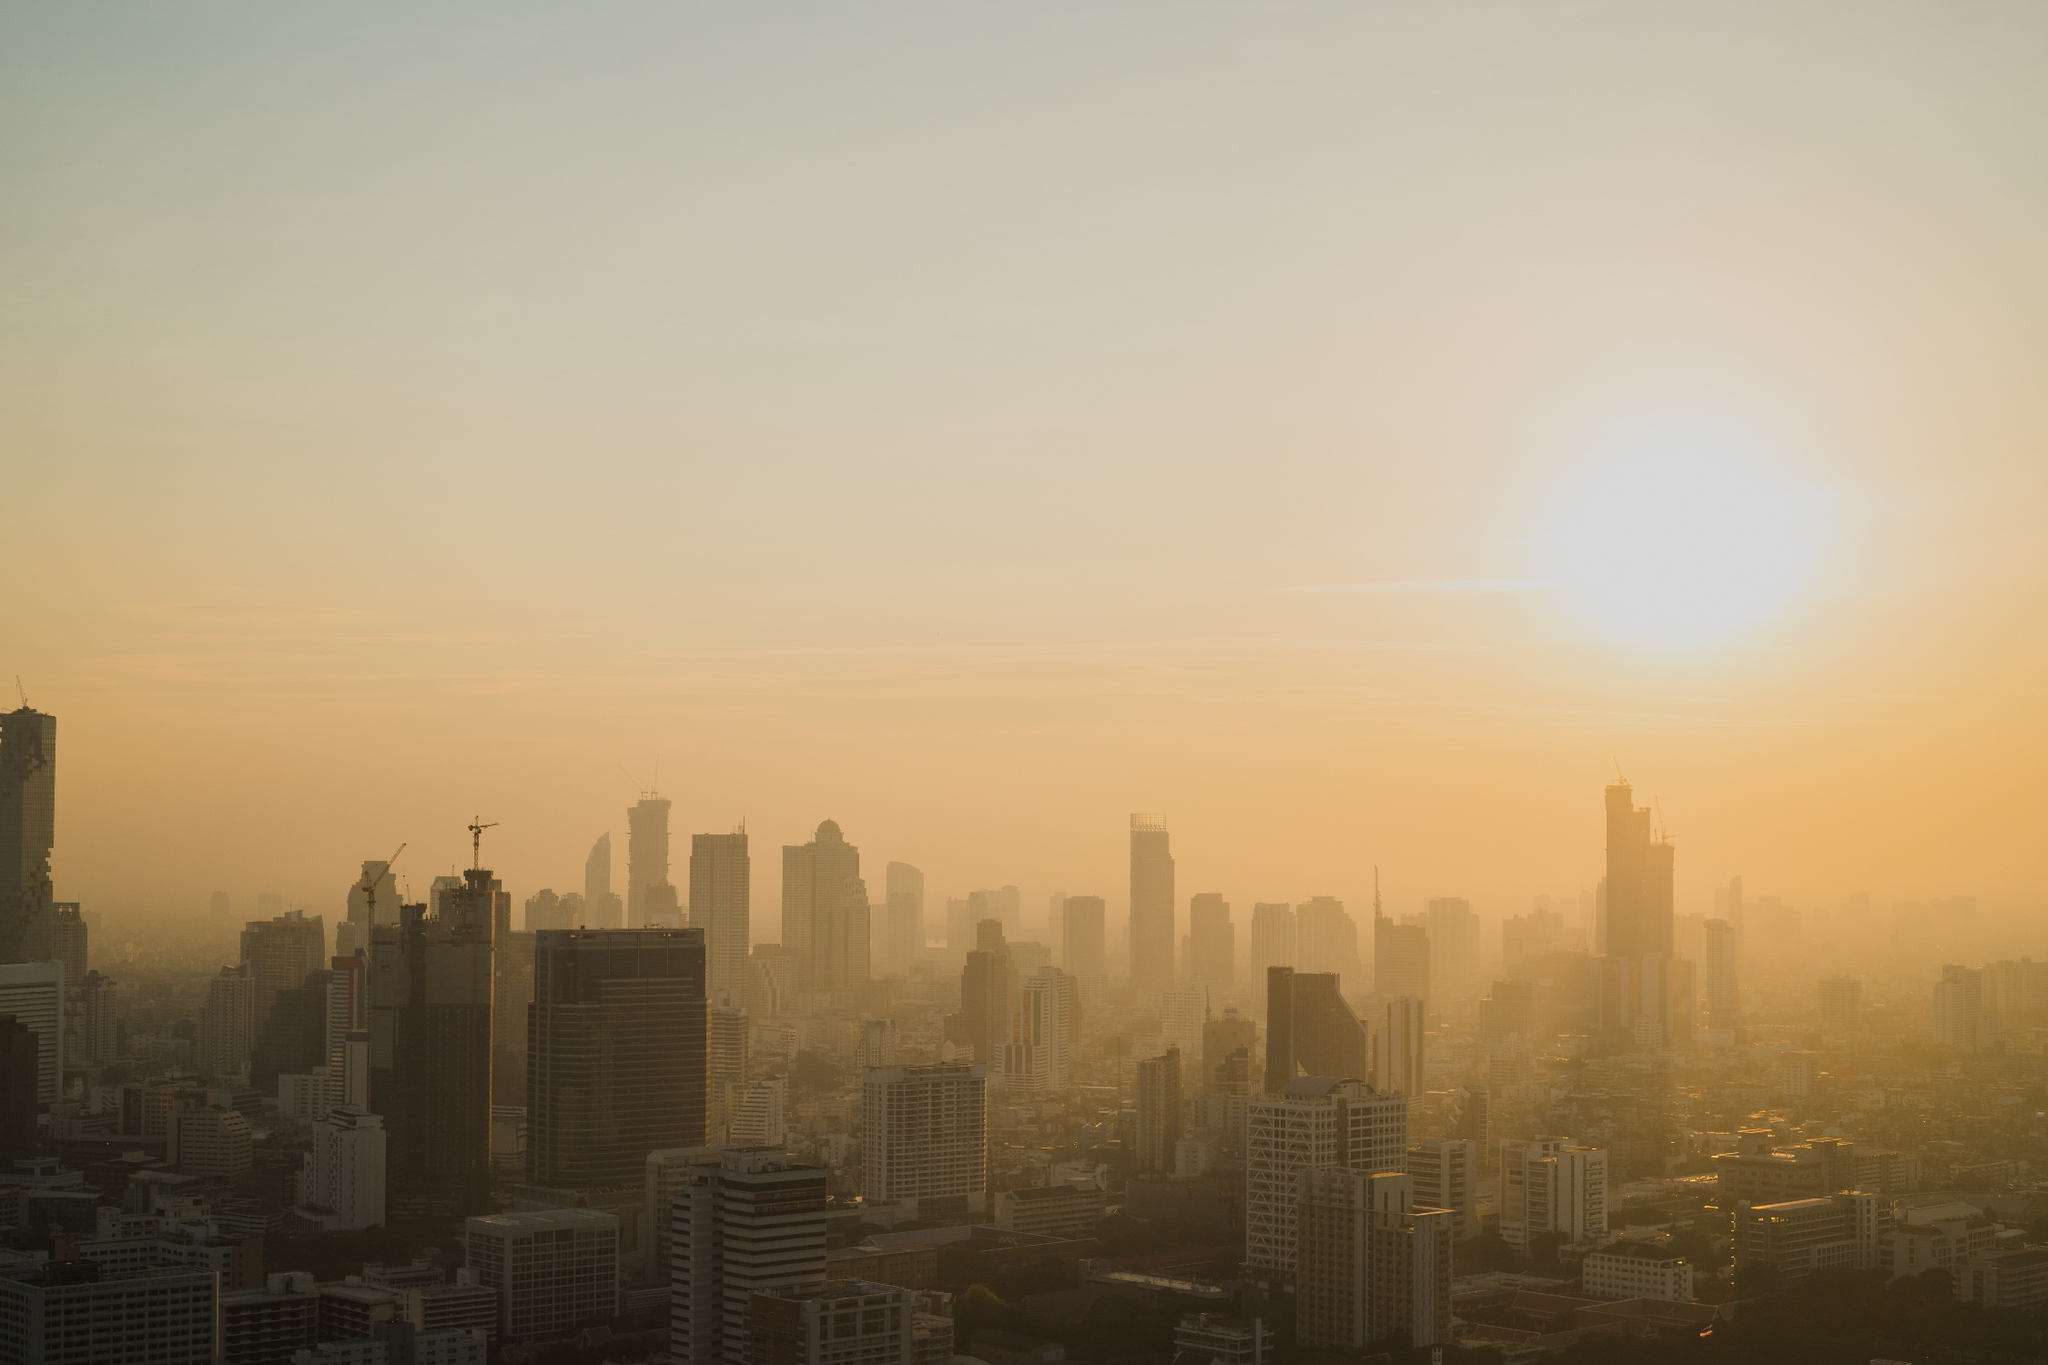What can you tell about the environmental conditions of the city? The orange hue in the sky signifies not only the time of day but also possible air pollution. It's common for large urban centers to struggle with air quality due to emissions from vehicles, industrial activities, and construction. The lack of visibility and presence of smog suggest a certain level of air pollution, which can affect the health of residents and the environment. Could you guess the time of day this image captures? Considering the sun's position near the horizon and the quality of the light, this image most likely captures the early hours of the morning. The quietness of the city and absence of visible traffic suggest it is taken at dawn before the city wakes up and becomes active. 